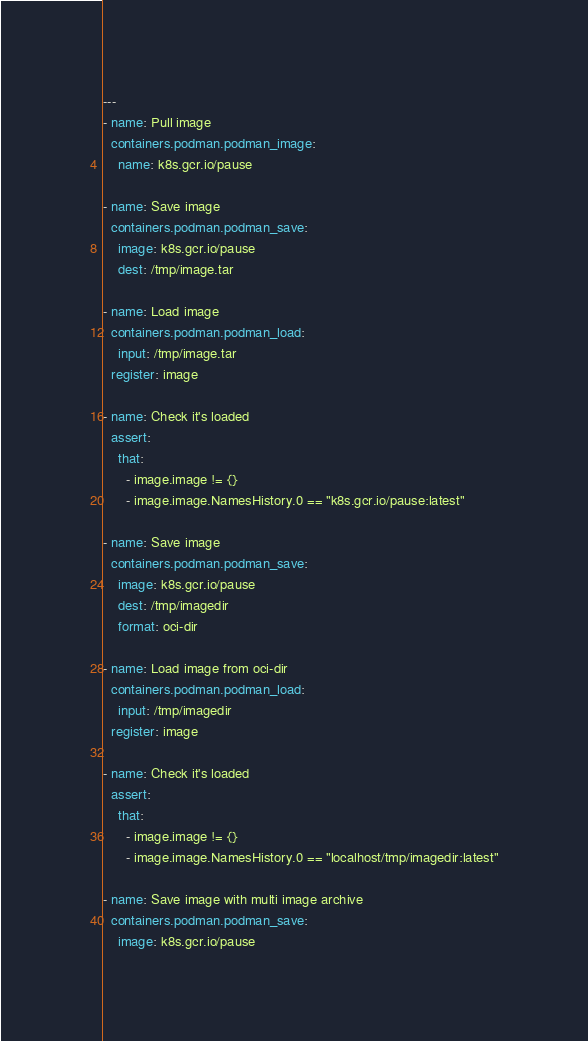<code> <loc_0><loc_0><loc_500><loc_500><_YAML_>---
- name: Pull image
  containers.podman.podman_image:
    name: k8s.gcr.io/pause

- name: Save image
  containers.podman.podman_save:
    image: k8s.gcr.io/pause
    dest: /tmp/image.tar

- name: Load image
  containers.podman.podman_load:
    input: /tmp/image.tar
  register: image

- name: Check it's loaded
  assert:
    that:
      - image.image != {}
      - image.image.NamesHistory.0 == "k8s.gcr.io/pause:latest"

- name: Save image
  containers.podman.podman_save:
    image: k8s.gcr.io/pause
    dest: /tmp/imagedir
    format: oci-dir

- name: Load image from oci-dir
  containers.podman.podman_load:
    input: /tmp/imagedir
  register: image

- name: Check it's loaded
  assert:
    that:
      - image.image != {}
      - image.image.NamesHistory.0 == "localhost/tmp/imagedir:latest"

- name: Save image with multi image archive
  containers.podman.podman_save:
    image: k8s.gcr.io/pause</code> 